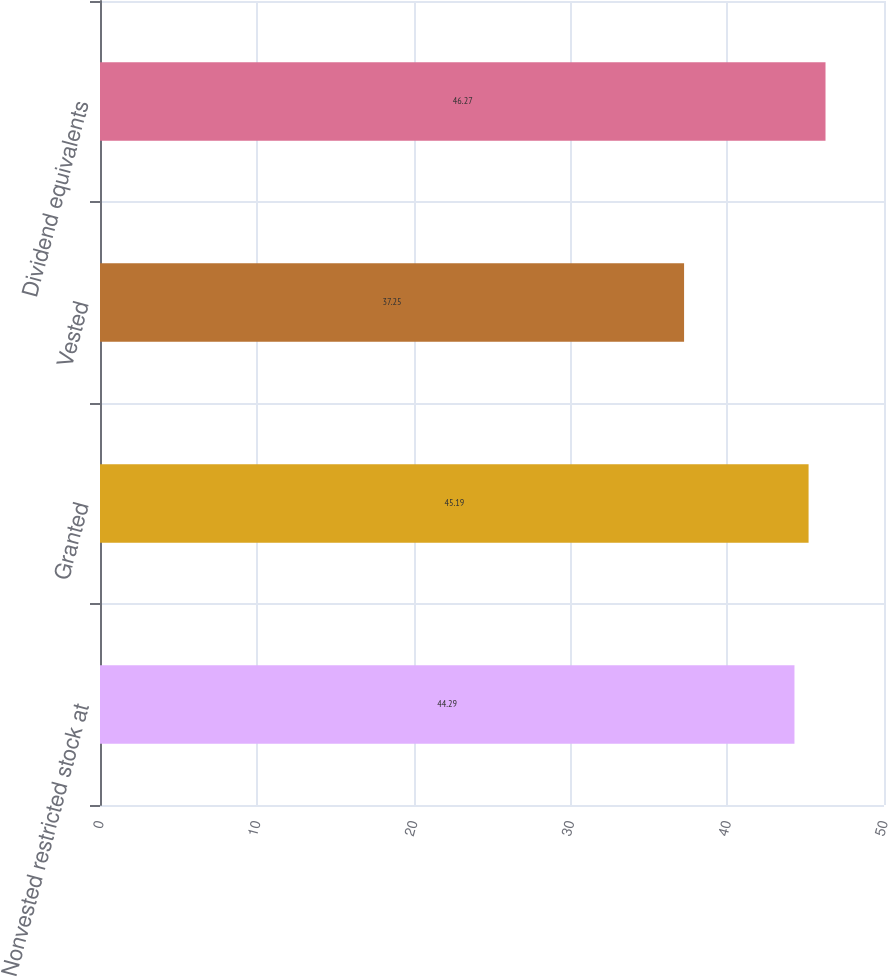Convert chart. <chart><loc_0><loc_0><loc_500><loc_500><bar_chart><fcel>Nonvested restricted stock at<fcel>Granted<fcel>Vested<fcel>Dividend equivalents<nl><fcel>44.29<fcel>45.19<fcel>37.25<fcel>46.27<nl></chart> 